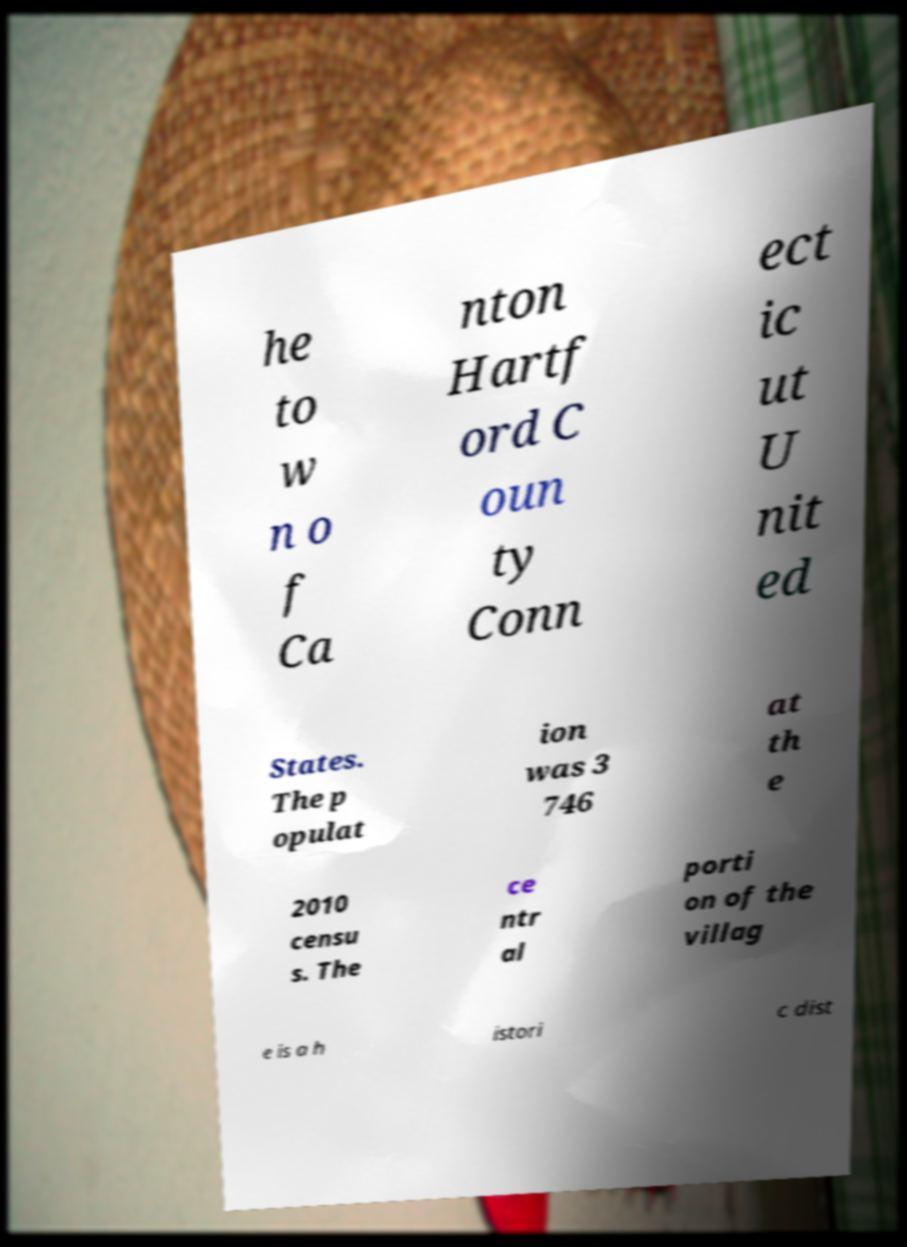Please read and relay the text visible in this image. What does it say? he to w n o f Ca nton Hartf ord C oun ty Conn ect ic ut U nit ed States. The p opulat ion was 3 746 at th e 2010 censu s. The ce ntr al porti on of the villag e is a h istori c dist 